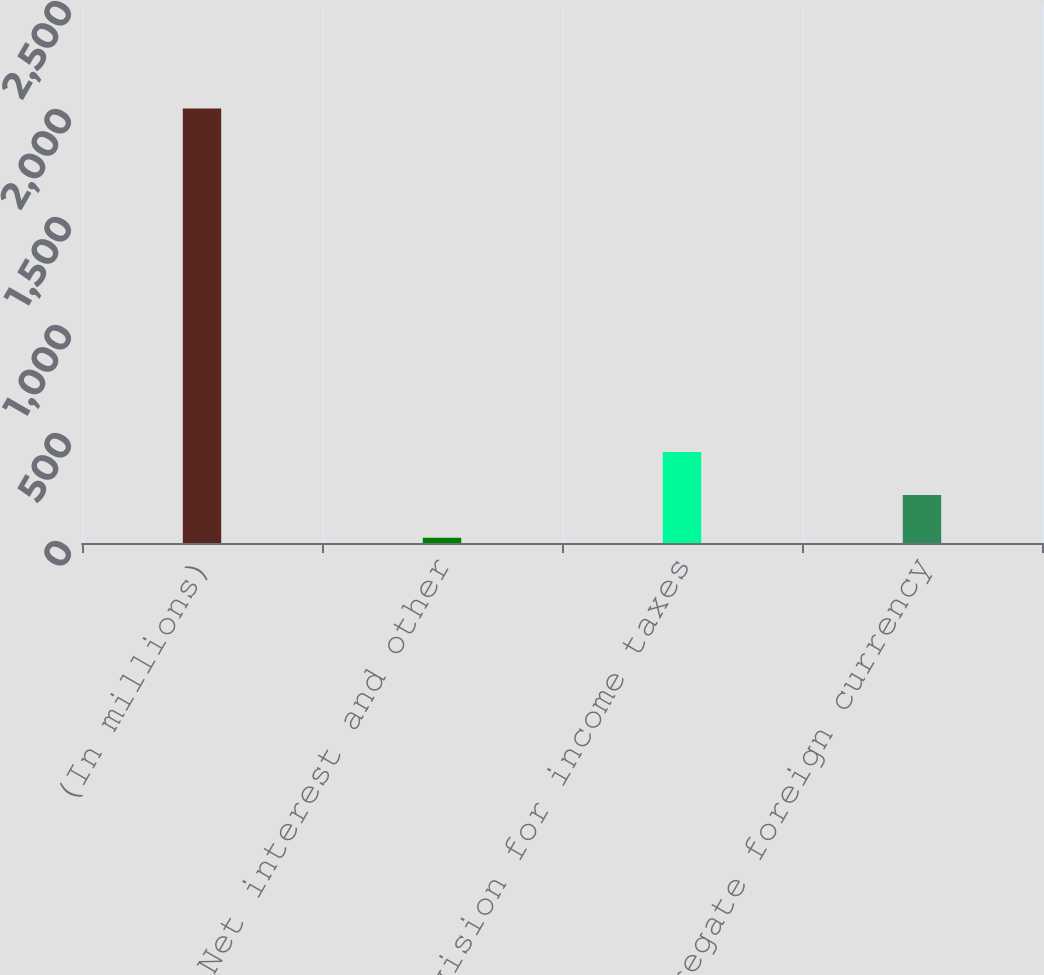Convert chart to OTSL. <chart><loc_0><loc_0><loc_500><loc_500><bar_chart><fcel>(In millions)<fcel>Net interest and other<fcel>Provision for income taxes<fcel>Aggregate foreign currency<nl><fcel>2011<fcel>24<fcel>421.4<fcel>222.7<nl></chart> 